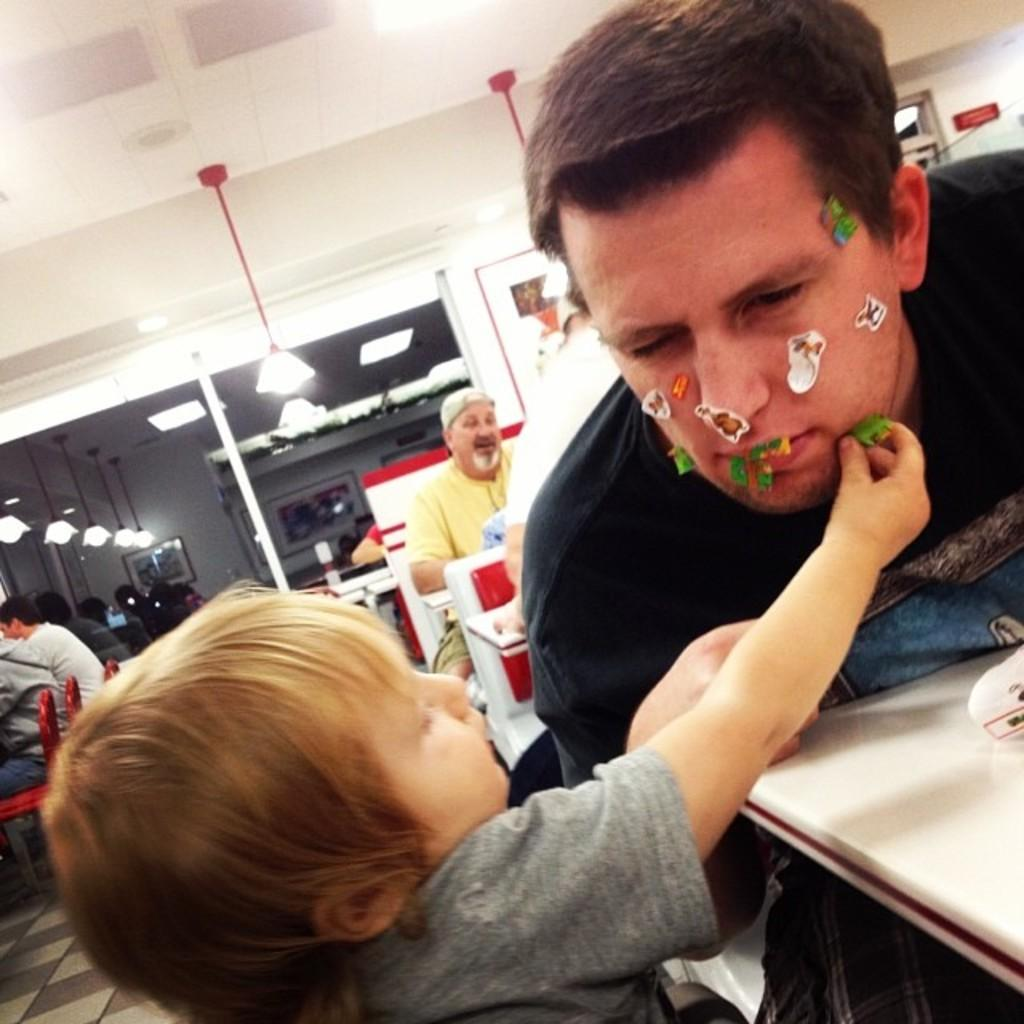What are the people in the image doing? The people in the image are sitting. What can be seen in the image besides the people? There are tables in the image. What is placed on the tables? Objects are placed on the tables. What activity is taking place involving a boy and a person's face? A boy is sticking stickers on a person's face. What type of sock is the person wearing in the image? There is no mention of a sock or any footwear in the image. 